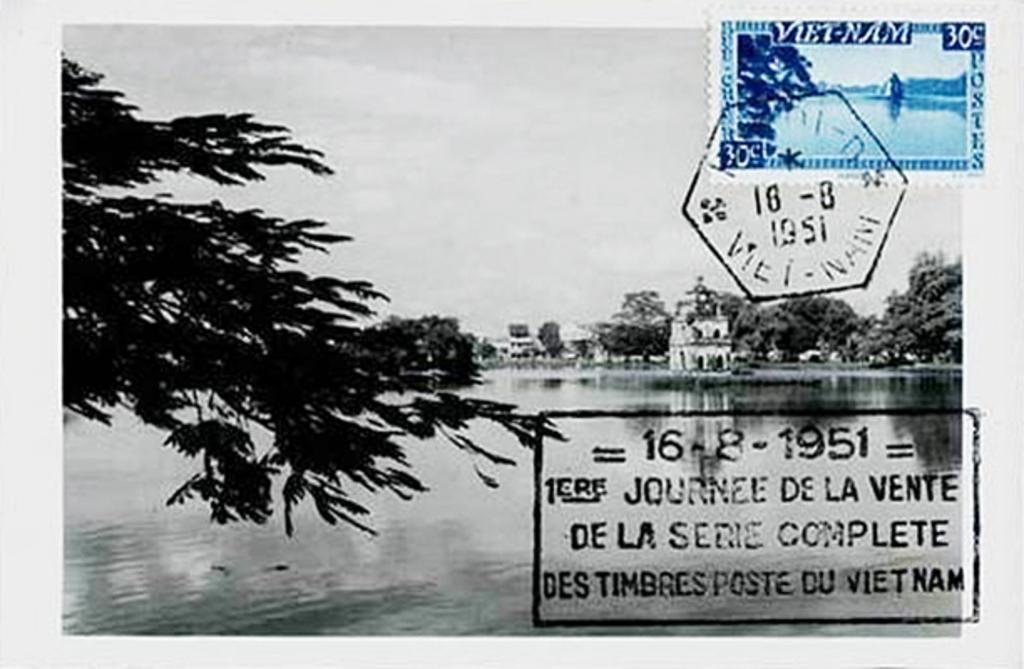Could you give a brief overview of what you see in this image? This is a black and white picture. At the bottom, we see water and this water might be in the lake. On the left side, we see a tree. There are trees and buildings in the background. At the top, we see the sky. On the right side, we see some text written. It might be the stamp. This picture might be a poster or it might be an edited image. 